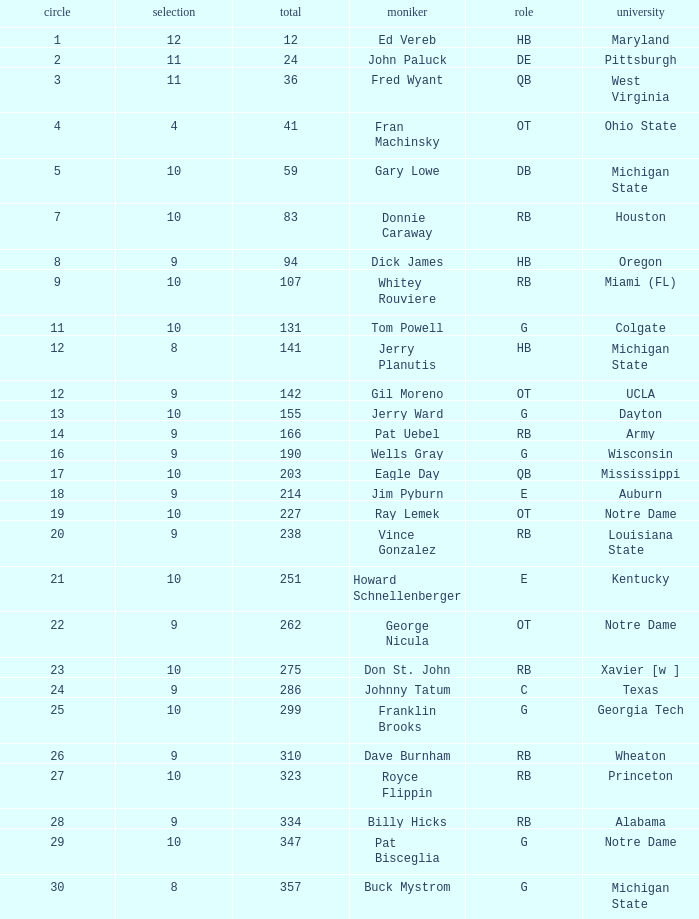What is the overall pick number for a draft pick smaller than 9, named buck mystrom from Michigan State college? 357.0. I'm looking to parse the entire table for insights. Could you assist me with that? {'header': ['circle', 'selection', 'total', 'moniker', 'role', 'university'], 'rows': [['1', '12', '12', 'Ed Vereb', 'HB', 'Maryland'], ['2', '11', '24', 'John Paluck', 'DE', 'Pittsburgh'], ['3', '11', '36', 'Fred Wyant', 'QB', 'West Virginia'], ['4', '4', '41', 'Fran Machinsky', 'OT', 'Ohio State'], ['5', '10', '59', 'Gary Lowe', 'DB', 'Michigan State'], ['7', '10', '83', 'Donnie Caraway', 'RB', 'Houston'], ['8', '9', '94', 'Dick James', 'HB', 'Oregon'], ['9', '10', '107', 'Whitey Rouviere', 'RB', 'Miami (FL)'], ['11', '10', '131', 'Tom Powell', 'G', 'Colgate'], ['12', '8', '141', 'Jerry Planutis', 'HB', 'Michigan State'], ['12', '9', '142', 'Gil Moreno', 'OT', 'UCLA'], ['13', '10', '155', 'Jerry Ward', 'G', 'Dayton'], ['14', '9', '166', 'Pat Uebel', 'RB', 'Army'], ['16', '9', '190', 'Wells Gray', 'G', 'Wisconsin'], ['17', '10', '203', 'Eagle Day', 'QB', 'Mississippi'], ['18', '9', '214', 'Jim Pyburn', 'E', 'Auburn'], ['19', '10', '227', 'Ray Lemek', 'OT', 'Notre Dame'], ['20', '9', '238', 'Vince Gonzalez', 'RB', 'Louisiana State'], ['21', '10', '251', 'Howard Schnellenberger', 'E', 'Kentucky'], ['22', '9', '262', 'George Nicula', 'OT', 'Notre Dame'], ['23', '10', '275', 'Don St. John', 'RB', 'Xavier [w ]'], ['24', '9', '286', 'Johnny Tatum', 'C', 'Texas'], ['25', '10', '299', 'Franklin Brooks', 'G', 'Georgia Tech'], ['26', '9', '310', 'Dave Burnham', 'RB', 'Wheaton'], ['27', '10', '323', 'Royce Flippin', 'RB', 'Princeton'], ['28', '9', '334', 'Billy Hicks', 'RB', 'Alabama'], ['29', '10', '347', 'Pat Bisceglia', 'G', 'Notre Dame'], ['30', '8', '357', 'Buck Mystrom', 'G', 'Michigan State']]} 